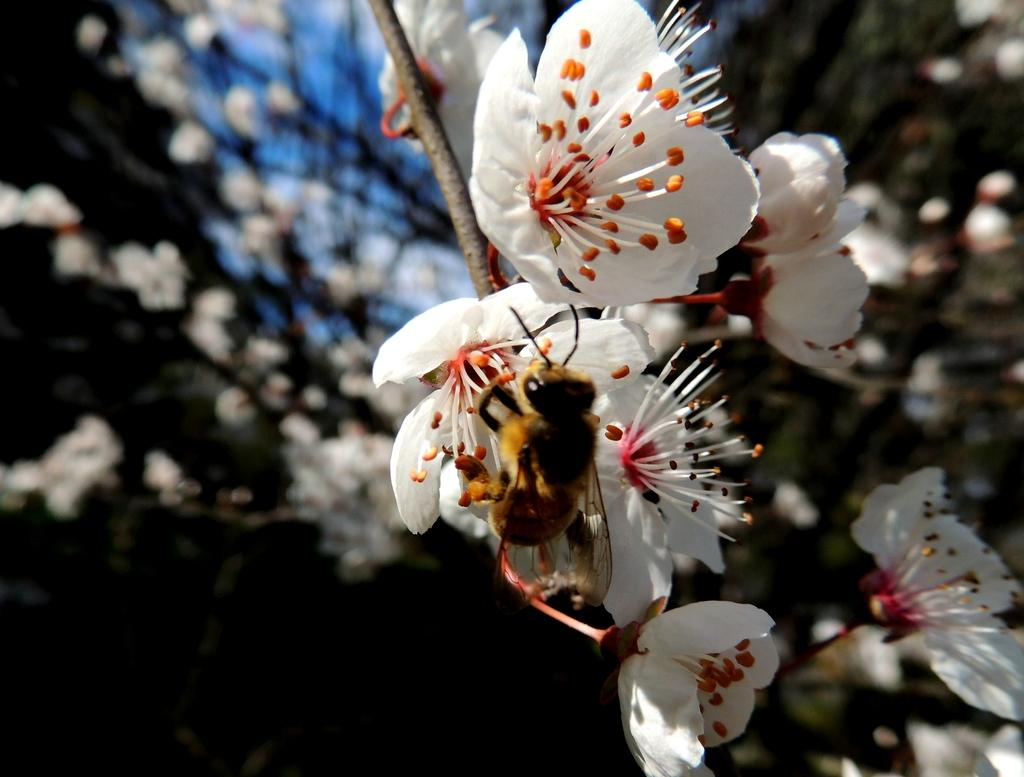What is present on the flower in the image? There is an insect on the flower in the image. What color is the flower that the insect is on? The flower is white. What can be seen in the background of the image? There are flowers visible in the background of the image. What is the color of the background in the image? The background has a green color. Can you tell me how many gloves are on the face of the insect in the image? There are no gloves or faces present on the insect in the image; it is just an insect on a flower. 